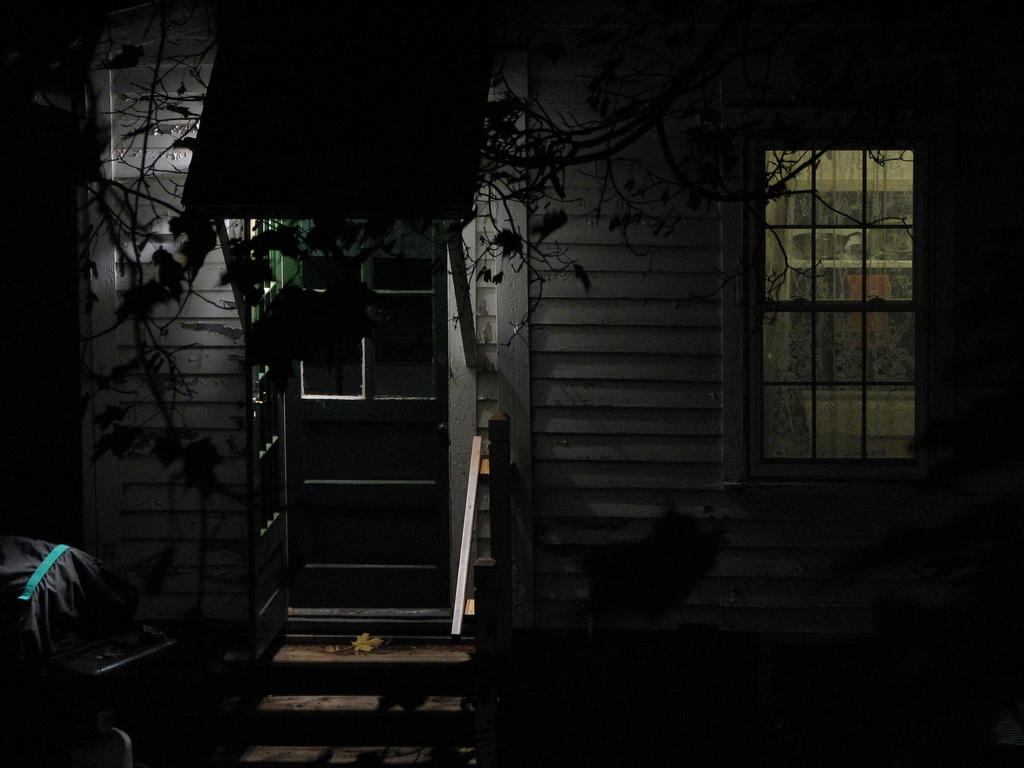What type of structure is in the picture? There is a house in the picture. What features can be seen on the house? The house has a window, a door, and steps. What natural element is present in the picture? There is a tree in the picture. Are there any other objects visible in the picture? Yes, there are other objects in the picture. What type of creature is sitting on the table in the picture? There is no table or creature present in the picture. What color is the bag that the creature is holding in the picture? There is no bag or creature present in the picture. 